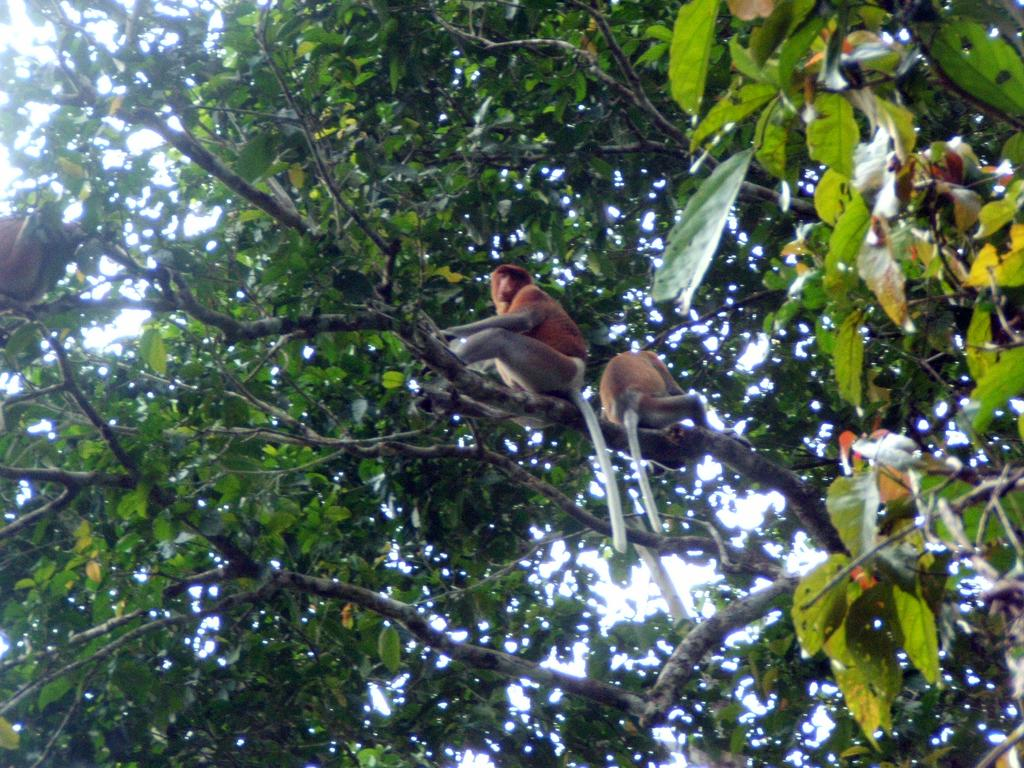What type of animals are present in the image? There are monkeys in the image. Where are the monkeys located? The monkeys are on a branch of a tree. What part of the tree is the jar smashed on in the image? There is no jar present in the image, so it cannot be smashed on any part of the tree. 